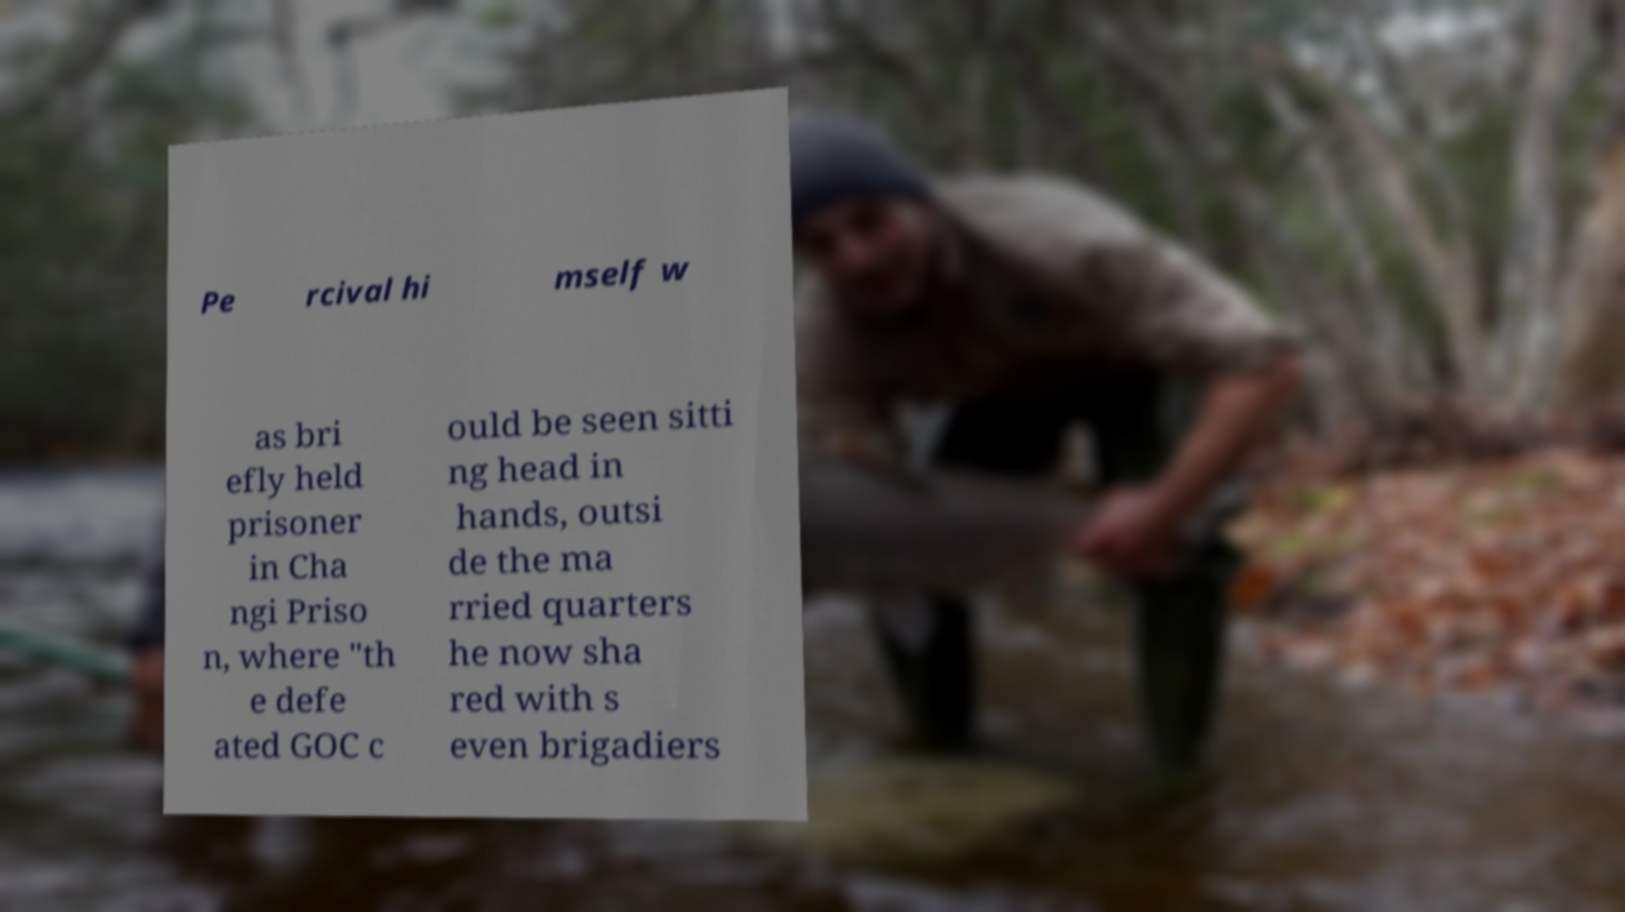Can you read and provide the text displayed in the image?This photo seems to have some interesting text. Can you extract and type it out for me? Pe rcival hi mself w as bri efly held prisoner in Cha ngi Priso n, where "th e defe ated GOC c ould be seen sitti ng head in hands, outsi de the ma rried quarters he now sha red with s even brigadiers 